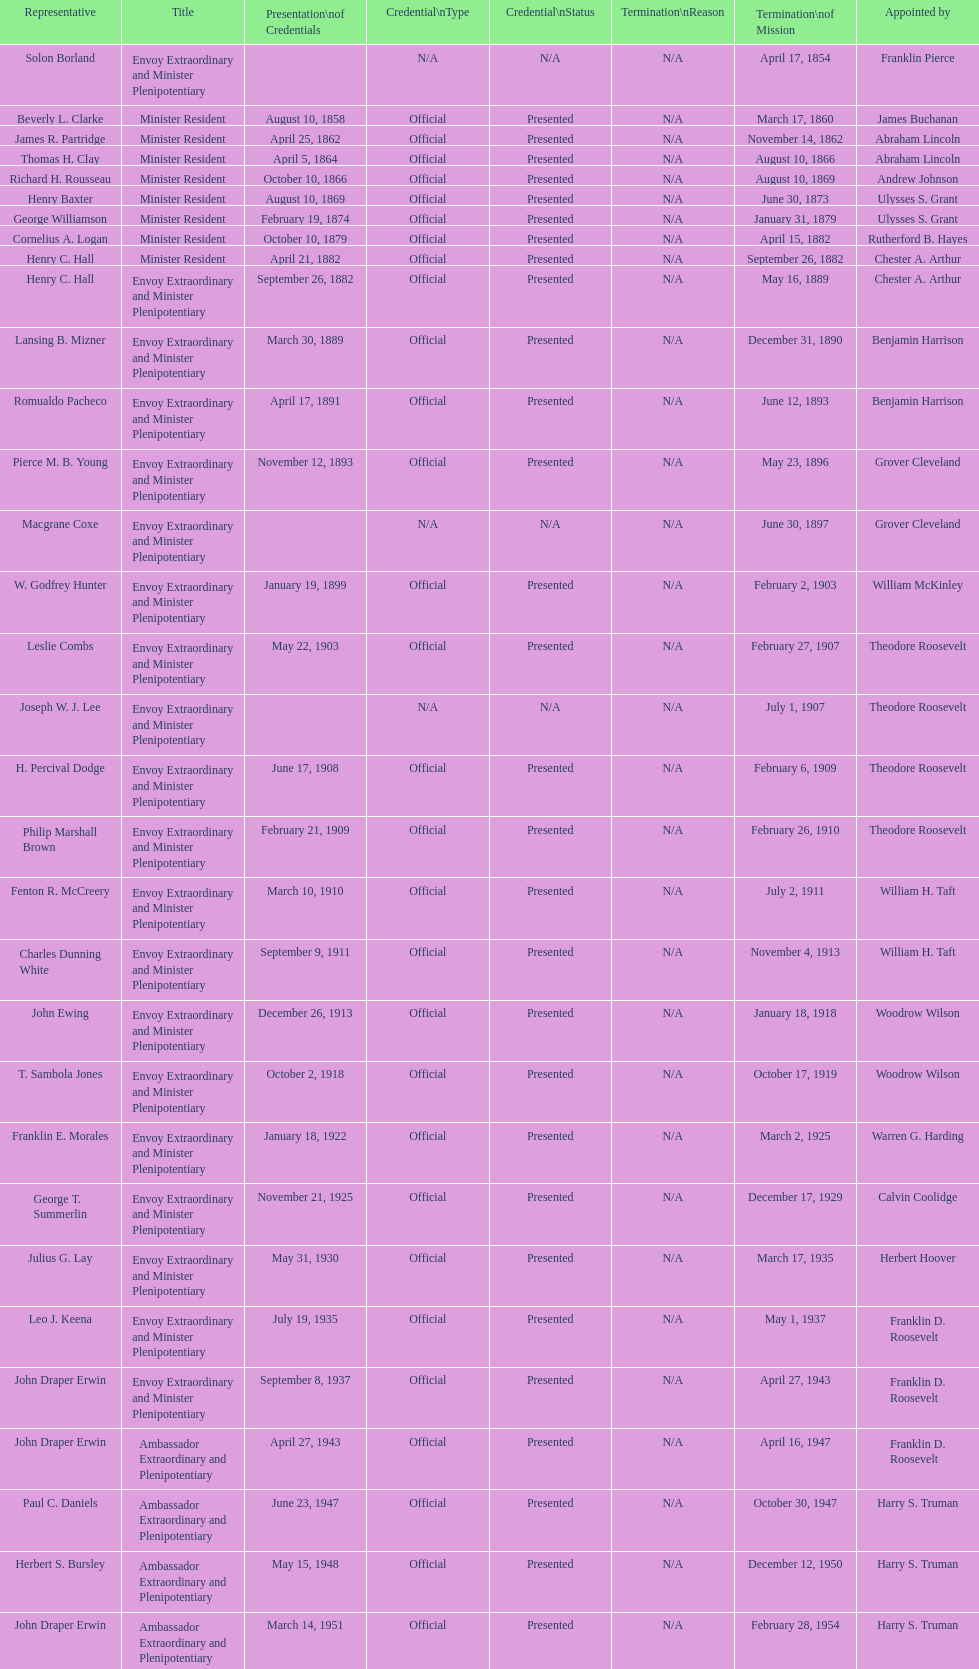Which minister resident had the shortest appointment? Henry C. Hall. 